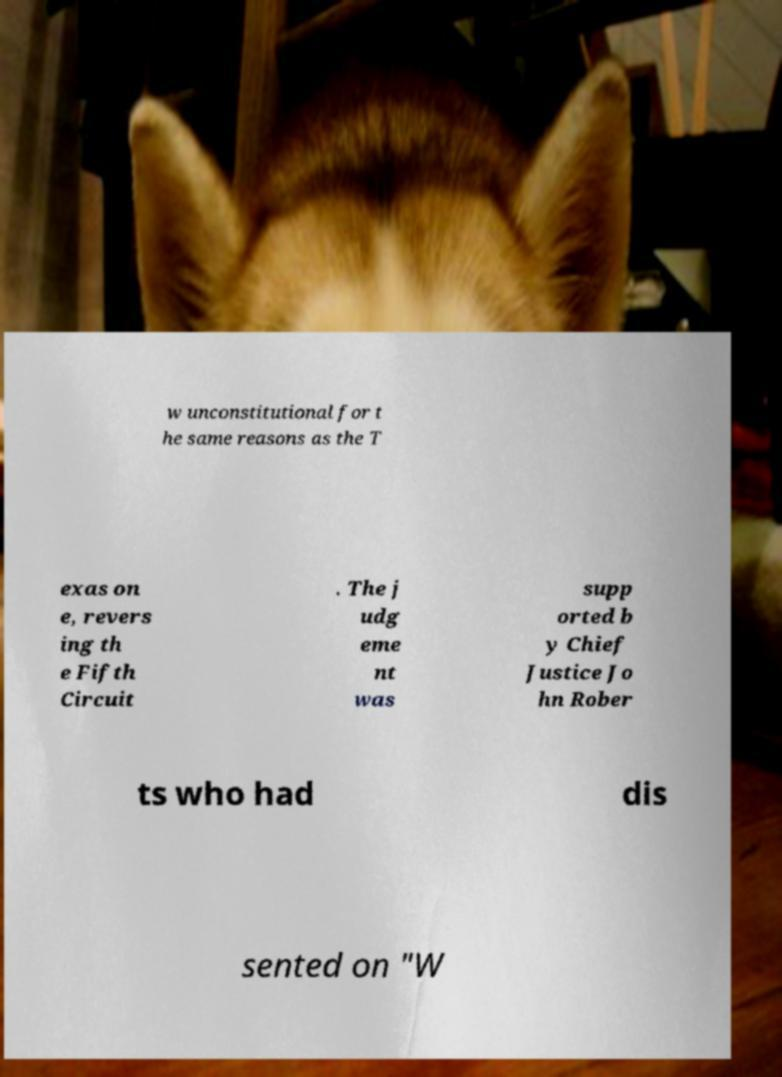Can you read and provide the text displayed in the image?This photo seems to have some interesting text. Can you extract and type it out for me? w unconstitutional for t he same reasons as the T exas on e, revers ing th e Fifth Circuit . The j udg eme nt was supp orted b y Chief Justice Jo hn Rober ts who had dis sented on "W 